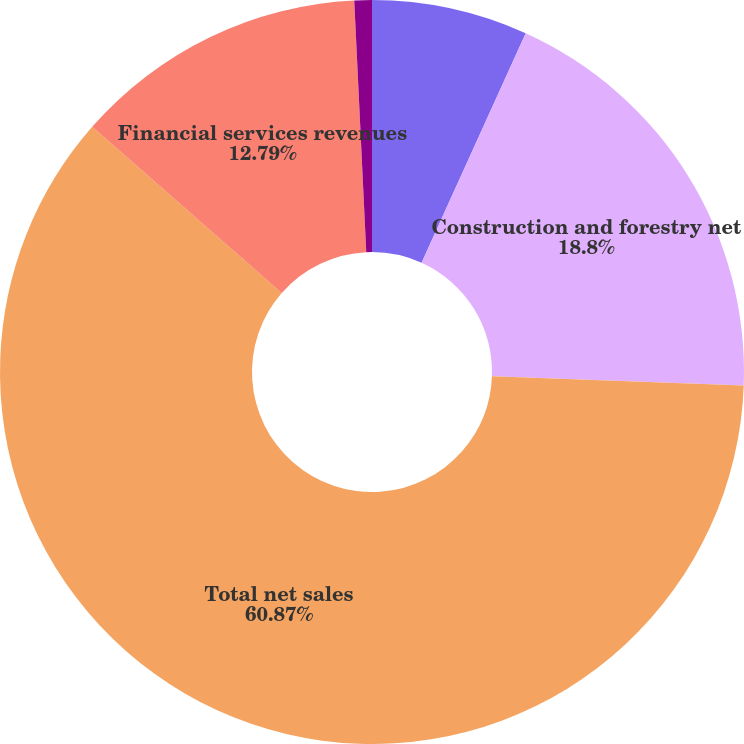<chart> <loc_0><loc_0><loc_500><loc_500><pie_chart><fcel>OPERATING SEGMENTS<fcel>Construction and forestry net<fcel>Total net sales<fcel>Financial services revenues<fcel>Other revenues<nl><fcel>6.78%<fcel>18.8%<fcel>60.87%<fcel>12.79%<fcel>0.76%<nl></chart> 